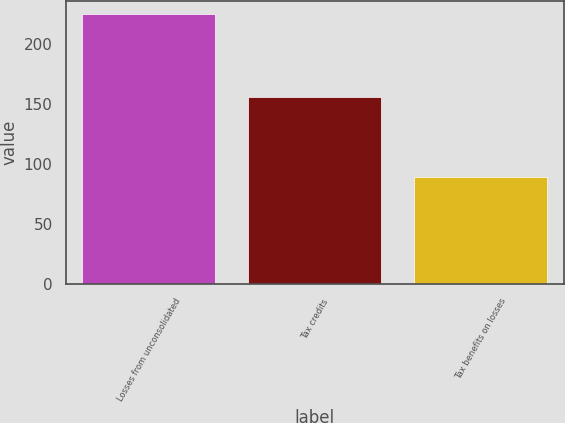<chart> <loc_0><loc_0><loc_500><loc_500><bar_chart><fcel>Losses from unconsolidated<fcel>Tax credits<fcel>Tax benefits on losses<nl><fcel>225<fcel>156<fcel>89<nl></chart> 